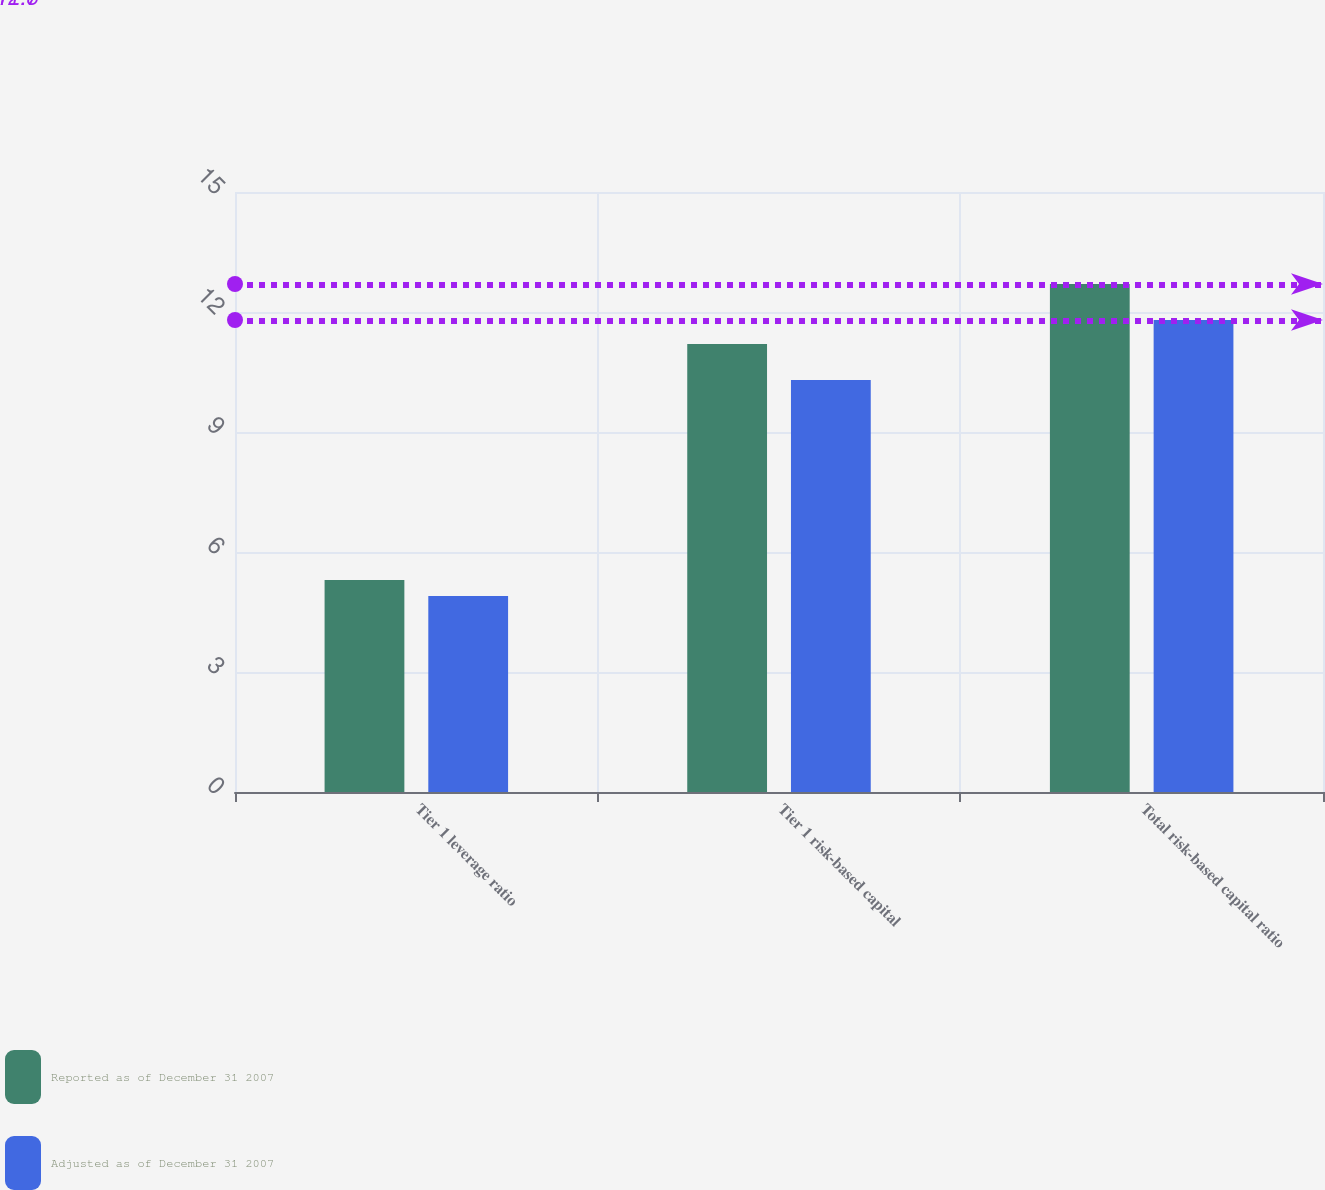Convert chart to OTSL. <chart><loc_0><loc_0><loc_500><loc_500><stacked_bar_chart><ecel><fcel>Tier 1 leverage ratio<fcel>Tier 1 risk-based capital<fcel>Total risk-based capital ratio<nl><fcel>Reported as of December 31 2007<fcel>5.3<fcel>11.2<fcel>12.7<nl><fcel>Adjusted as of December 31 2007<fcel>4.9<fcel>10.3<fcel>11.8<nl></chart> 